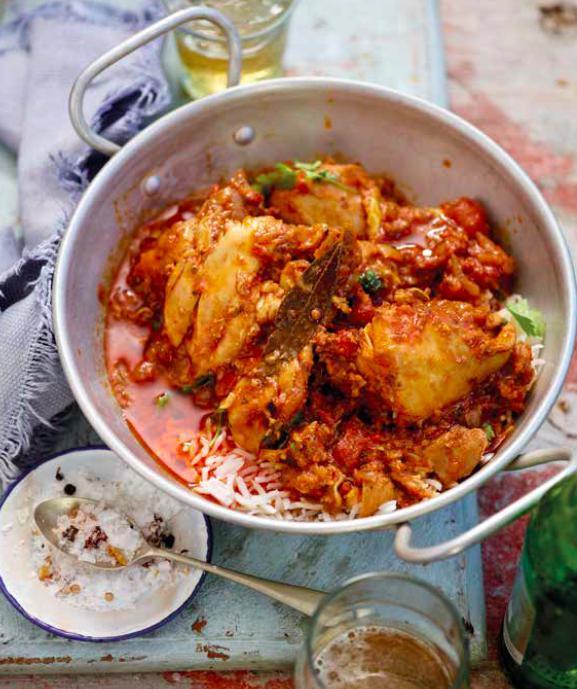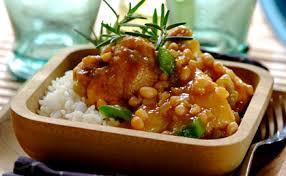The first image is the image on the left, the second image is the image on the right. Evaluate the accuracy of this statement regarding the images: "One image shows a one-pot meal in a round container with two handles that is not sitting on a heat source.". Is it true? Answer yes or no. Yes. The first image is the image on the left, the second image is the image on the right. For the images displayed, is the sentence "Food is on a plate in one of the images." factually correct? Answer yes or no. No. 